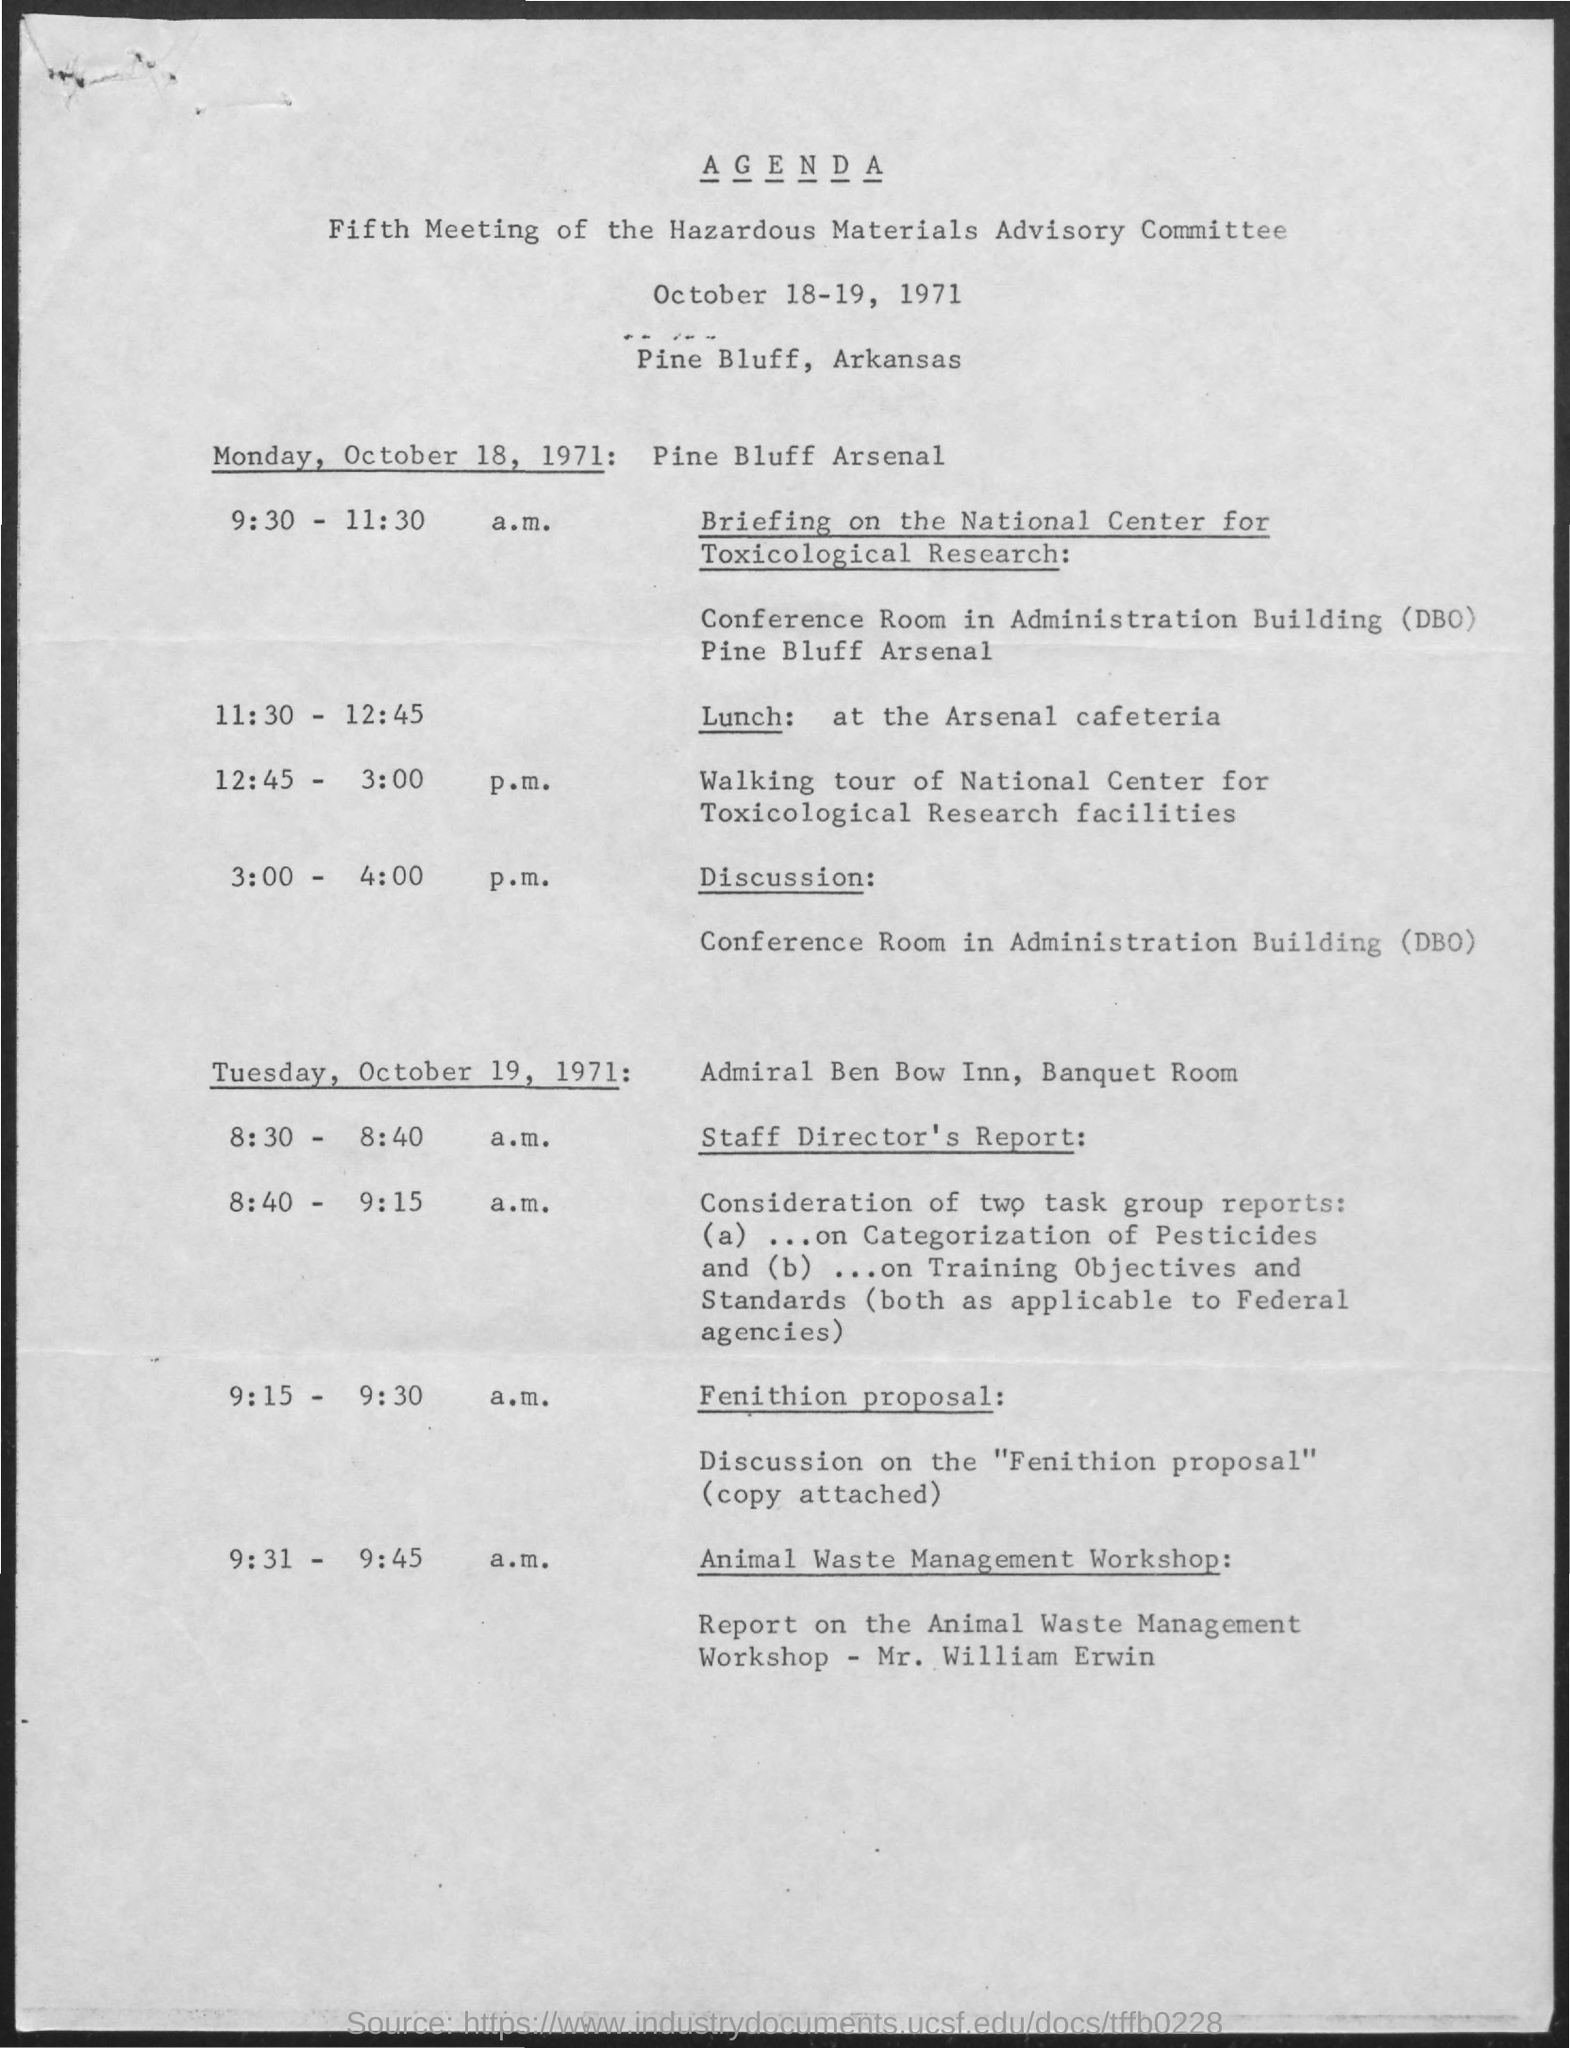When is the committee meeting held?
Your answer should be very brief. October 18-19, 1971. Where is it held?
Give a very brief answer. Pine bluff, arkansas. When is the lunch?
Give a very brief answer. 11:30 - 12:45. Where is the lunch held?
Make the answer very short. Arsenal Cafeteria. Where is the meeting held on Monday, October 18, 1971?
Your response must be concise. Pine Bluff Arsenal. Where is the meeting held on Tuesday, October 19, 1971?
Your response must be concise. Adimiral Ben Bow Inn, Banquet Room. 